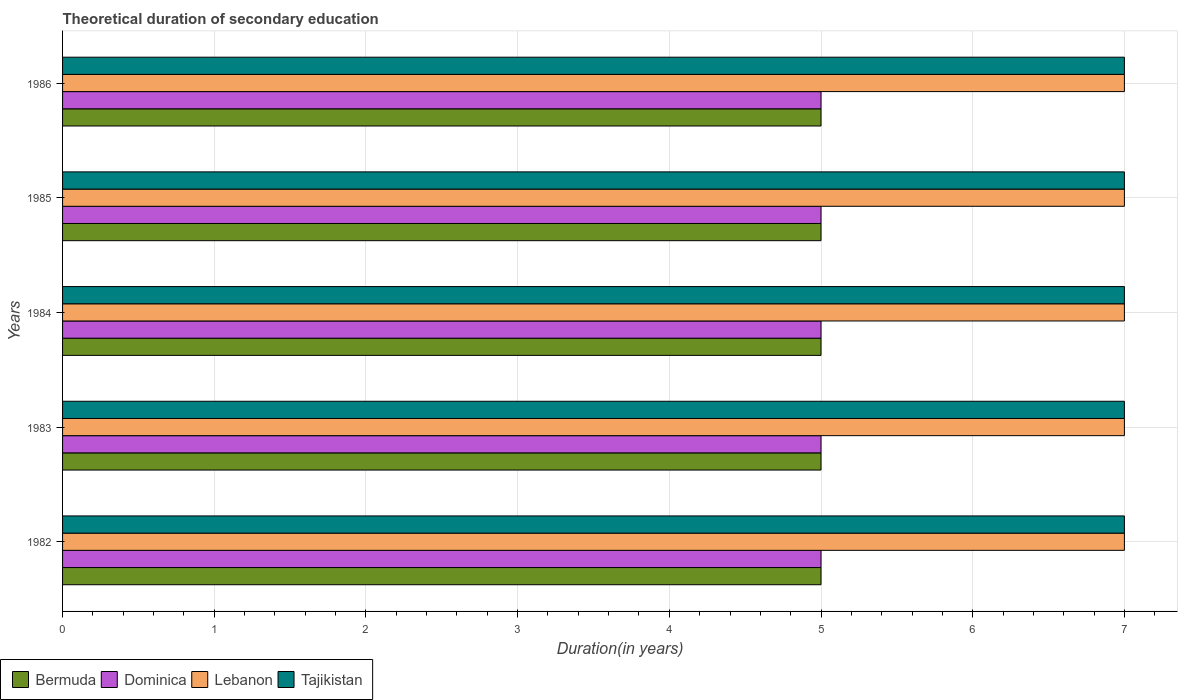How many different coloured bars are there?
Provide a short and direct response. 4. Are the number of bars per tick equal to the number of legend labels?
Your response must be concise. Yes. How many bars are there on the 5th tick from the top?
Offer a very short reply. 4. What is the total theoretical duration of secondary education in Dominica in 1986?
Make the answer very short. 5. Across all years, what is the maximum total theoretical duration of secondary education in Tajikistan?
Ensure brevity in your answer.  7. Across all years, what is the minimum total theoretical duration of secondary education in Tajikistan?
Offer a very short reply. 7. What is the total total theoretical duration of secondary education in Tajikistan in the graph?
Offer a very short reply. 35. What is the difference between the total theoretical duration of secondary education in Lebanon in 1983 and that in 1984?
Give a very brief answer. 0. What is the difference between the total theoretical duration of secondary education in Dominica in 1983 and the total theoretical duration of secondary education in Tajikistan in 1982?
Ensure brevity in your answer.  -2. In the year 1985, what is the difference between the total theoretical duration of secondary education in Lebanon and total theoretical duration of secondary education in Dominica?
Offer a very short reply. 2. In how many years, is the total theoretical duration of secondary education in Tajikistan greater than 2.6 years?
Your answer should be very brief. 5. Is the total theoretical duration of secondary education in Tajikistan in 1982 less than that in 1983?
Provide a short and direct response. No. Is the difference between the total theoretical duration of secondary education in Lebanon in 1984 and 1986 greater than the difference between the total theoretical duration of secondary education in Dominica in 1984 and 1986?
Make the answer very short. No. What is the difference between the highest and the lowest total theoretical duration of secondary education in Lebanon?
Provide a short and direct response. 0. In how many years, is the total theoretical duration of secondary education in Dominica greater than the average total theoretical duration of secondary education in Dominica taken over all years?
Keep it short and to the point. 0. Is the sum of the total theoretical duration of secondary education in Bermuda in 1982 and 1985 greater than the maximum total theoretical duration of secondary education in Lebanon across all years?
Your answer should be compact. Yes. Is it the case that in every year, the sum of the total theoretical duration of secondary education in Dominica and total theoretical duration of secondary education in Tajikistan is greater than the sum of total theoretical duration of secondary education in Lebanon and total theoretical duration of secondary education in Bermuda?
Keep it short and to the point. Yes. What does the 1st bar from the top in 1986 represents?
Provide a short and direct response. Tajikistan. What does the 3rd bar from the bottom in 1982 represents?
Provide a short and direct response. Lebanon. Are all the bars in the graph horizontal?
Give a very brief answer. Yes. Are the values on the major ticks of X-axis written in scientific E-notation?
Provide a short and direct response. No. Where does the legend appear in the graph?
Ensure brevity in your answer.  Bottom left. How many legend labels are there?
Ensure brevity in your answer.  4. How are the legend labels stacked?
Provide a succinct answer. Horizontal. What is the title of the graph?
Ensure brevity in your answer.  Theoretical duration of secondary education. Does "Macedonia" appear as one of the legend labels in the graph?
Make the answer very short. No. What is the label or title of the X-axis?
Offer a very short reply. Duration(in years). What is the Duration(in years) in Lebanon in 1982?
Offer a terse response. 7. What is the Duration(in years) in Bermuda in 1983?
Your response must be concise. 5. What is the Duration(in years) of Dominica in 1983?
Your answer should be very brief. 5. What is the Duration(in years) of Bermuda in 1984?
Give a very brief answer. 5. What is the Duration(in years) in Bermuda in 1985?
Ensure brevity in your answer.  5. What is the Duration(in years) of Dominica in 1986?
Your answer should be very brief. 5. Across all years, what is the maximum Duration(in years) of Bermuda?
Offer a terse response. 5. Across all years, what is the maximum Duration(in years) in Lebanon?
Your answer should be compact. 7. Across all years, what is the minimum Duration(in years) of Dominica?
Make the answer very short. 5. Across all years, what is the minimum Duration(in years) of Lebanon?
Keep it short and to the point. 7. What is the total Duration(in years) in Bermuda in the graph?
Keep it short and to the point. 25. What is the total Duration(in years) of Dominica in the graph?
Ensure brevity in your answer.  25. What is the difference between the Duration(in years) in Bermuda in 1982 and that in 1983?
Your response must be concise. 0. What is the difference between the Duration(in years) of Lebanon in 1982 and that in 1983?
Make the answer very short. 0. What is the difference between the Duration(in years) of Bermuda in 1982 and that in 1984?
Give a very brief answer. 0. What is the difference between the Duration(in years) in Dominica in 1982 and that in 1984?
Your response must be concise. 0. What is the difference between the Duration(in years) in Lebanon in 1982 and that in 1984?
Offer a terse response. 0. What is the difference between the Duration(in years) in Tajikistan in 1982 and that in 1984?
Your answer should be very brief. 0. What is the difference between the Duration(in years) of Lebanon in 1982 and that in 1985?
Offer a very short reply. 0. What is the difference between the Duration(in years) in Tajikistan in 1982 and that in 1985?
Make the answer very short. 0. What is the difference between the Duration(in years) of Dominica in 1982 and that in 1986?
Offer a terse response. 0. What is the difference between the Duration(in years) in Tajikistan in 1982 and that in 1986?
Offer a very short reply. 0. What is the difference between the Duration(in years) in Dominica in 1983 and that in 1984?
Give a very brief answer. 0. What is the difference between the Duration(in years) of Lebanon in 1983 and that in 1984?
Your answer should be very brief. 0. What is the difference between the Duration(in years) in Tajikistan in 1983 and that in 1984?
Offer a terse response. 0. What is the difference between the Duration(in years) in Bermuda in 1983 and that in 1985?
Keep it short and to the point. 0. What is the difference between the Duration(in years) of Bermuda in 1983 and that in 1986?
Your answer should be compact. 0. What is the difference between the Duration(in years) of Lebanon in 1983 and that in 1986?
Give a very brief answer. 0. What is the difference between the Duration(in years) in Lebanon in 1984 and that in 1985?
Ensure brevity in your answer.  0. What is the difference between the Duration(in years) of Tajikistan in 1984 and that in 1985?
Offer a terse response. 0. What is the difference between the Duration(in years) of Bermuda in 1985 and that in 1986?
Your answer should be compact. 0. What is the difference between the Duration(in years) in Dominica in 1985 and that in 1986?
Provide a succinct answer. 0. What is the difference between the Duration(in years) in Tajikistan in 1985 and that in 1986?
Give a very brief answer. 0. What is the difference between the Duration(in years) of Bermuda in 1982 and the Duration(in years) of Tajikistan in 1983?
Your answer should be very brief. -2. What is the difference between the Duration(in years) of Dominica in 1982 and the Duration(in years) of Lebanon in 1983?
Offer a very short reply. -2. What is the difference between the Duration(in years) in Lebanon in 1982 and the Duration(in years) in Tajikistan in 1983?
Give a very brief answer. 0. What is the difference between the Duration(in years) in Bermuda in 1982 and the Duration(in years) in Tajikistan in 1984?
Offer a very short reply. -2. What is the difference between the Duration(in years) of Dominica in 1982 and the Duration(in years) of Tajikistan in 1984?
Make the answer very short. -2. What is the difference between the Duration(in years) of Bermuda in 1982 and the Duration(in years) of Tajikistan in 1985?
Keep it short and to the point. -2. What is the difference between the Duration(in years) in Lebanon in 1982 and the Duration(in years) in Tajikistan in 1985?
Offer a terse response. 0. What is the difference between the Duration(in years) of Bermuda in 1982 and the Duration(in years) of Dominica in 1986?
Your answer should be compact. 0. What is the difference between the Duration(in years) of Bermuda in 1982 and the Duration(in years) of Lebanon in 1986?
Your response must be concise. -2. What is the difference between the Duration(in years) in Dominica in 1982 and the Duration(in years) in Tajikistan in 1986?
Keep it short and to the point. -2. What is the difference between the Duration(in years) in Lebanon in 1982 and the Duration(in years) in Tajikistan in 1986?
Make the answer very short. 0. What is the difference between the Duration(in years) in Bermuda in 1983 and the Duration(in years) in Dominica in 1984?
Ensure brevity in your answer.  0. What is the difference between the Duration(in years) in Bermuda in 1983 and the Duration(in years) in Tajikistan in 1984?
Ensure brevity in your answer.  -2. What is the difference between the Duration(in years) of Dominica in 1983 and the Duration(in years) of Lebanon in 1984?
Offer a very short reply. -2. What is the difference between the Duration(in years) of Dominica in 1983 and the Duration(in years) of Tajikistan in 1984?
Keep it short and to the point. -2. What is the difference between the Duration(in years) of Bermuda in 1983 and the Duration(in years) of Lebanon in 1985?
Give a very brief answer. -2. What is the difference between the Duration(in years) of Dominica in 1983 and the Duration(in years) of Lebanon in 1985?
Your response must be concise. -2. What is the difference between the Duration(in years) in Lebanon in 1983 and the Duration(in years) in Tajikistan in 1985?
Make the answer very short. 0. What is the difference between the Duration(in years) in Bermuda in 1983 and the Duration(in years) in Lebanon in 1986?
Offer a terse response. -2. What is the difference between the Duration(in years) in Dominica in 1983 and the Duration(in years) in Lebanon in 1986?
Provide a short and direct response. -2. What is the difference between the Duration(in years) of Dominica in 1983 and the Duration(in years) of Tajikistan in 1986?
Provide a succinct answer. -2. What is the difference between the Duration(in years) of Bermuda in 1984 and the Duration(in years) of Tajikistan in 1985?
Your response must be concise. -2. What is the difference between the Duration(in years) in Dominica in 1984 and the Duration(in years) in Tajikistan in 1985?
Give a very brief answer. -2. What is the difference between the Duration(in years) in Bermuda in 1984 and the Duration(in years) in Lebanon in 1986?
Make the answer very short. -2. What is the difference between the Duration(in years) in Lebanon in 1984 and the Duration(in years) in Tajikistan in 1986?
Your answer should be compact. 0. What is the difference between the Duration(in years) of Bermuda in 1985 and the Duration(in years) of Dominica in 1986?
Give a very brief answer. 0. What is the difference between the Duration(in years) of Bermuda in 1985 and the Duration(in years) of Lebanon in 1986?
Offer a terse response. -2. What is the average Duration(in years) in Bermuda per year?
Keep it short and to the point. 5. What is the average Duration(in years) of Dominica per year?
Offer a very short reply. 5. What is the average Duration(in years) in Tajikistan per year?
Offer a very short reply. 7. In the year 1982, what is the difference between the Duration(in years) in Dominica and Duration(in years) in Lebanon?
Your answer should be very brief. -2. In the year 1982, what is the difference between the Duration(in years) in Dominica and Duration(in years) in Tajikistan?
Your response must be concise. -2. In the year 1983, what is the difference between the Duration(in years) in Bermuda and Duration(in years) in Lebanon?
Offer a very short reply. -2. In the year 1983, what is the difference between the Duration(in years) of Bermuda and Duration(in years) of Tajikistan?
Ensure brevity in your answer.  -2. In the year 1983, what is the difference between the Duration(in years) of Dominica and Duration(in years) of Tajikistan?
Keep it short and to the point. -2. In the year 1984, what is the difference between the Duration(in years) of Bermuda and Duration(in years) of Dominica?
Offer a very short reply. 0. In the year 1984, what is the difference between the Duration(in years) of Bermuda and Duration(in years) of Lebanon?
Give a very brief answer. -2. In the year 1984, what is the difference between the Duration(in years) of Dominica and Duration(in years) of Lebanon?
Offer a very short reply. -2. In the year 1985, what is the difference between the Duration(in years) of Bermuda and Duration(in years) of Dominica?
Offer a very short reply. 0. In the year 1985, what is the difference between the Duration(in years) of Dominica and Duration(in years) of Lebanon?
Ensure brevity in your answer.  -2. In the year 1985, what is the difference between the Duration(in years) of Dominica and Duration(in years) of Tajikistan?
Offer a terse response. -2. In the year 1985, what is the difference between the Duration(in years) in Lebanon and Duration(in years) in Tajikistan?
Your answer should be compact. 0. In the year 1986, what is the difference between the Duration(in years) of Bermuda and Duration(in years) of Dominica?
Give a very brief answer. 0. In the year 1986, what is the difference between the Duration(in years) in Bermuda and Duration(in years) in Lebanon?
Provide a succinct answer. -2. In the year 1986, what is the difference between the Duration(in years) of Dominica and Duration(in years) of Lebanon?
Your answer should be compact. -2. What is the ratio of the Duration(in years) in Tajikistan in 1982 to that in 1983?
Offer a very short reply. 1. What is the ratio of the Duration(in years) of Dominica in 1982 to that in 1984?
Your answer should be compact. 1. What is the ratio of the Duration(in years) of Lebanon in 1982 to that in 1984?
Your response must be concise. 1. What is the ratio of the Duration(in years) in Tajikistan in 1982 to that in 1984?
Provide a short and direct response. 1. What is the ratio of the Duration(in years) of Bermuda in 1982 to that in 1985?
Provide a short and direct response. 1. What is the ratio of the Duration(in years) of Lebanon in 1982 to that in 1985?
Provide a short and direct response. 1. What is the ratio of the Duration(in years) of Tajikistan in 1982 to that in 1985?
Keep it short and to the point. 1. What is the ratio of the Duration(in years) of Dominica in 1982 to that in 1986?
Provide a short and direct response. 1. What is the ratio of the Duration(in years) in Lebanon in 1982 to that in 1986?
Offer a terse response. 1. What is the ratio of the Duration(in years) of Tajikistan in 1982 to that in 1986?
Make the answer very short. 1. What is the ratio of the Duration(in years) of Bermuda in 1983 to that in 1984?
Provide a short and direct response. 1. What is the ratio of the Duration(in years) in Tajikistan in 1983 to that in 1984?
Offer a terse response. 1. What is the ratio of the Duration(in years) in Bermuda in 1983 to that in 1985?
Make the answer very short. 1. What is the ratio of the Duration(in years) in Dominica in 1983 to that in 1985?
Give a very brief answer. 1. What is the ratio of the Duration(in years) in Lebanon in 1983 to that in 1985?
Give a very brief answer. 1. What is the ratio of the Duration(in years) in Tajikistan in 1984 to that in 1985?
Make the answer very short. 1. What is the ratio of the Duration(in years) of Bermuda in 1984 to that in 1986?
Give a very brief answer. 1. What is the ratio of the Duration(in years) in Lebanon in 1984 to that in 1986?
Keep it short and to the point. 1. What is the ratio of the Duration(in years) in Bermuda in 1985 to that in 1986?
Provide a succinct answer. 1. What is the ratio of the Duration(in years) in Dominica in 1985 to that in 1986?
Offer a terse response. 1. What is the difference between the highest and the second highest Duration(in years) of Bermuda?
Your response must be concise. 0. What is the difference between the highest and the second highest Duration(in years) of Dominica?
Give a very brief answer. 0. What is the difference between the highest and the second highest Duration(in years) in Tajikistan?
Your response must be concise. 0. What is the difference between the highest and the lowest Duration(in years) of Dominica?
Provide a short and direct response. 0. What is the difference between the highest and the lowest Duration(in years) of Tajikistan?
Ensure brevity in your answer.  0. 